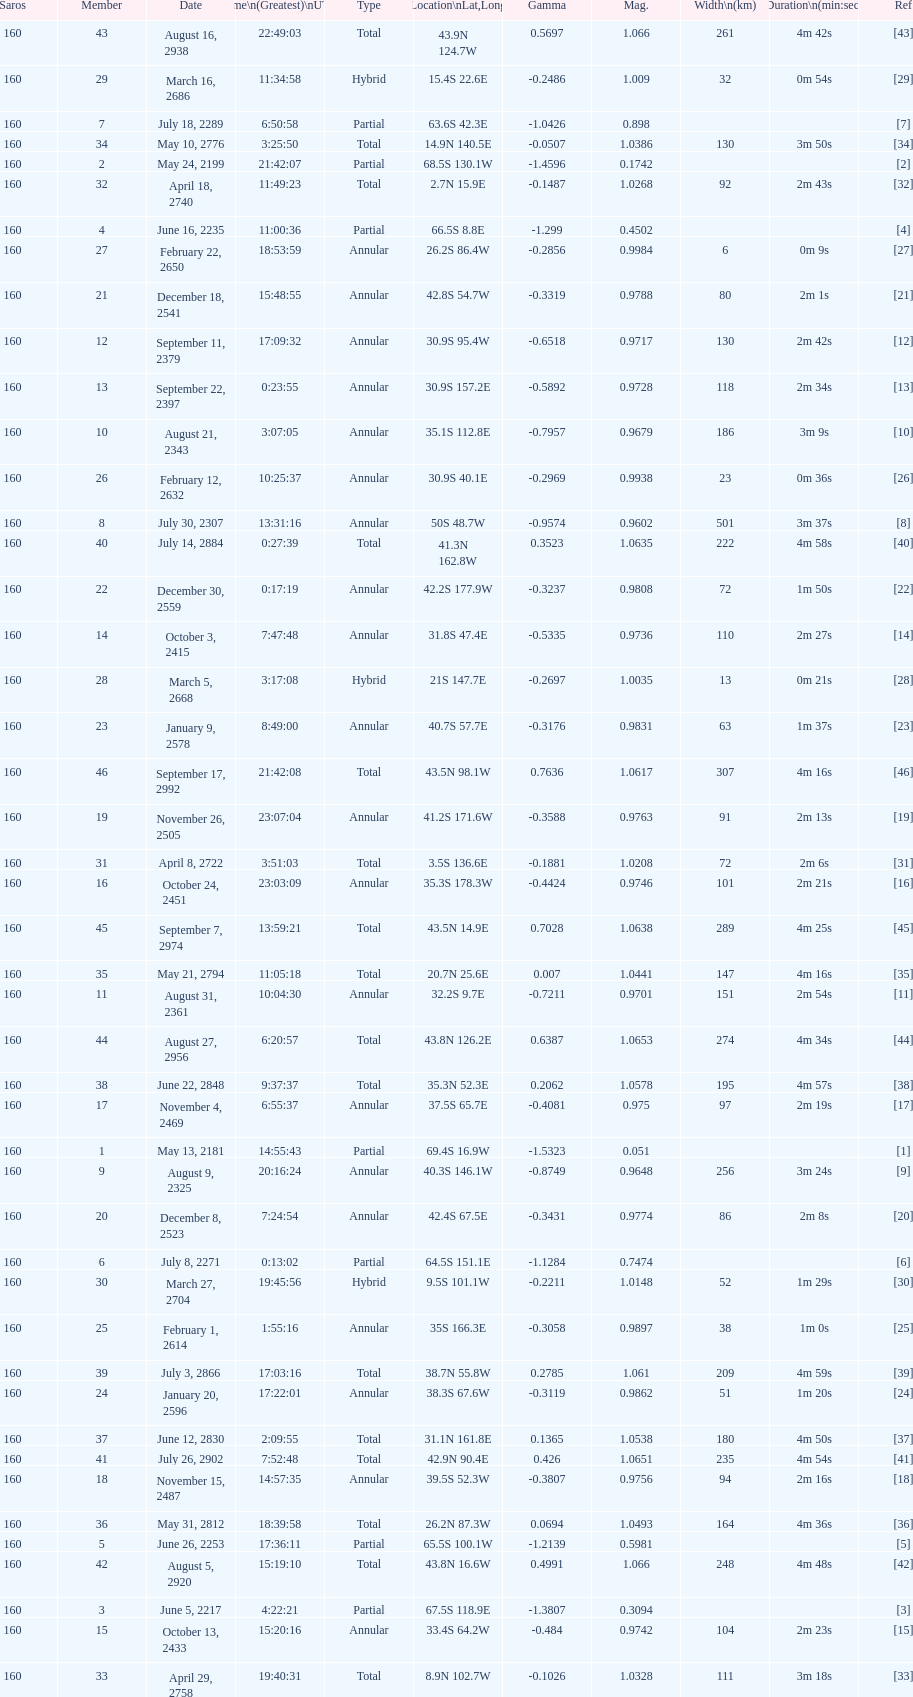Name one that has the same latitude as member number 12. 13. 